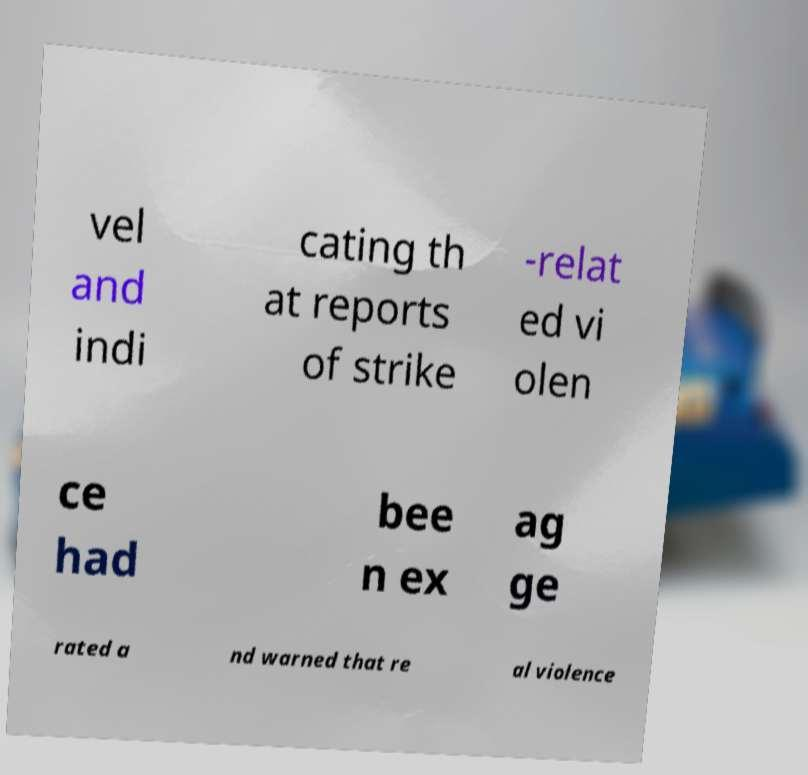For documentation purposes, I need the text within this image transcribed. Could you provide that? vel and indi cating th at reports of strike -relat ed vi olen ce had bee n ex ag ge rated a nd warned that re al violence 